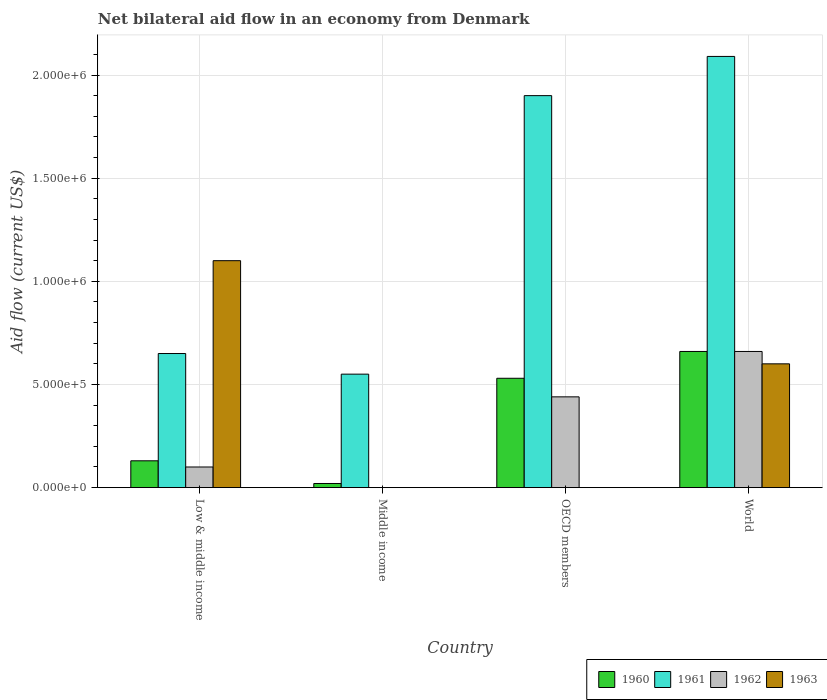How many groups of bars are there?
Keep it short and to the point. 4. What is the net bilateral aid flow in 1961 in OECD members?
Offer a terse response. 1.90e+06. What is the total net bilateral aid flow in 1961 in the graph?
Your response must be concise. 5.19e+06. What is the difference between the net bilateral aid flow in 1961 in Middle income and that in OECD members?
Provide a succinct answer. -1.35e+06. What is the difference between the net bilateral aid flow in 1961 in Low & middle income and the net bilateral aid flow in 1963 in OECD members?
Provide a short and direct response. 6.50e+05. In how many countries, is the net bilateral aid flow in 1960 greater than 600000 US$?
Provide a short and direct response. 1. What is the ratio of the net bilateral aid flow in 1961 in Middle income to that in OECD members?
Provide a short and direct response. 0.29. Is the difference between the net bilateral aid flow in 1963 in Low & middle income and World greater than the difference between the net bilateral aid flow in 1962 in Low & middle income and World?
Offer a terse response. Yes. What is the difference between the highest and the second highest net bilateral aid flow in 1961?
Provide a succinct answer. 1.44e+06. What is the difference between the highest and the lowest net bilateral aid flow in 1963?
Provide a short and direct response. 1.10e+06. In how many countries, is the net bilateral aid flow in 1961 greater than the average net bilateral aid flow in 1961 taken over all countries?
Make the answer very short. 2. Is it the case that in every country, the sum of the net bilateral aid flow in 1960 and net bilateral aid flow in 1963 is greater than the net bilateral aid flow in 1961?
Offer a terse response. No. How many bars are there?
Offer a very short reply. 13. Are all the bars in the graph horizontal?
Give a very brief answer. No. How many countries are there in the graph?
Ensure brevity in your answer.  4. What is the difference between two consecutive major ticks on the Y-axis?
Provide a short and direct response. 5.00e+05. Does the graph contain any zero values?
Make the answer very short. Yes. Does the graph contain grids?
Keep it short and to the point. Yes. How many legend labels are there?
Give a very brief answer. 4. How are the legend labels stacked?
Ensure brevity in your answer.  Horizontal. What is the title of the graph?
Ensure brevity in your answer.  Net bilateral aid flow in an economy from Denmark. What is the label or title of the X-axis?
Ensure brevity in your answer.  Country. What is the label or title of the Y-axis?
Provide a short and direct response. Aid flow (current US$). What is the Aid flow (current US$) of 1960 in Low & middle income?
Offer a very short reply. 1.30e+05. What is the Aid flow (current US$) of 1961 in Low & middle income?
Your answer should be compact. 6.50e+05. What is the Aid flow (current US$) in 1963 in Low & middle income?
Your answer should be very brief. 1.10e+06. What is the Aid flow (current US$) of 1962 in Middle income?
Give a very brief answer. 0. What is the Aid flow (current US$) in 1960 in OECD members?
Give a very brief answer. 5.30e+05. What is the Aid flow (current US$) of 1961 in OECD members?
Offer a terse response. 1.90e+06. What is the Aid flow (current US$) of 1963 in OECD members?
Your answer should be very brief. 0. What is the Aid flow (current US$) in 1961 in World?
Ensure brevity in your answer.  2.09e+06. What is the Aid flow (current US$) in 1962 in World?
Provide a succinct answer. 6.60e+05. What is the Aid flow (current US$) of 1963 in World?
Your answer should be very brief. 6.00e+05. Across all countries, what is the maximum Aid flow (current US$) of 1960?
Provide a short and direct response. 6.60e+05. Across all countries, what is the maximum Aid flow (current US$) in 1961?
Keep it short and to the point. 2.09e+06. Across all countries, what is the maximum Aid flow (current US$) of 1963?
Make the answer very short. 1.10e+06. Across all countries, what is the minimum Aid flow (current US$) in 1960?
Give a very brief answer. 2.00e+04. Across all countries, what is the minimum Aid flow (current US$) in 1961?
Provide a short and direct response. 5.50e+05. Across all countries, what is the minimum Aid flow (current US$) of 1962?
Offer a very short reply. 0. Across all countries, what is the minimum Aid flow (current US$) of 1963?
Provide a succinct answer. 0. What is the total Aid flow (current US$) in 1960 in the graph?
Make the answer very short. 1.34e+06. What is the total Aid flow (current US$) in 1961 in the graph?
Give a very brief answer. 5.19e+06. What is the total Aid flow (current US$) of 1962 in the graph?
Your answer should be compact. 1.20e+06. What is the total Aid flow (current US$) of 1963 in the graph?
Make the answer very short. 1.70e+06. What is the difference between the Aid flow (current US$) of 1960 in Low & middle income and that in Middle income?
Your response must be concise. 1.10e+05. What is the difference between the Aid flow (current US$) in 1960 in Low & middle income and that in OECD members?
Your answer should be very brief. -4.00e+05. What is the difference between the Aid flow (current US$) of 1961 in Low & middle income and that in OECD members?
Make the answer very short. -1.25e+06. What is the difference between the Aid flow (current US$) of 1962 in Low & middle income and that in OECD members?
Offer a terse response. -3.40e+05. What is the difference between the Aid flow (current US$) of 1960 in Low & middle income and that in World?
Make the answer very short. -5.30e+05. What is the difference between the Aid flow (current US$) of 1961 in Low & middle income and that in World?
Give a very brief answer. -1.44e+06. What is the difference between the Aid flow (current US$) in 1962 in Low & middle income and that in World?
Give a very brief answer. -5.60e+05. What is the difference between the Aid flow (current US$) of 1963 in Low & middle income and that in World?
Give a very brief answer. 5.00e+05. What is the difference between the Aid flow (current US$) in 1960 in Middle income and that in OECD members?
Your answer should be very brief. -5.10e+05. What is the difference between the Aid flow (current US$) in 1961 in Middle income and that in OECD members?
Your answer should be very brief. -1.35e+06. What is the difference between the Aid flow (current US$) of 1960 in Middle income and that in World?
Your answer should be compact. -6.40e+05. What is the difference between the Aid flow (current US$) in 1961 in Middle income and that in World?
Make the answer very short. -1.54e+06. What is the difference between the Aid flow (current US$) in 1960 in OECD members and that in World?
Make the answer very short. -1.30e+05. What is the difference between the Aid flow (current US$) in 1960 in Low & middle income and the Aid flow (current US$) in 1961 in Middle income?
Keep it short and to the point. -4.20e+05. What is the difference between the Aid flow (current US$) of 1960 in Low & middle income and the Aid flow (current US$) of 1961 in OECD members?
Keep it short and to the point. -1.77e+06. What is the difference between the Aid flow (current US$) of 1960 in Low & middle income and the Aid flow (current US$) of 1962 in OECD members?
Keep it short and to the point. -3.10e+05. What is the difference between the Aid flow (current US$) in 1961 in Low & middle income and the Aid flow (current US$) in 1962 in OECD members?
Provide a short and direct response. 2.10e+05. What is the difference between the Aid flow (current US$) in 1960 in Low & middle income and the Aid flow (current US$) in 1961 in World?
Your answer should be compact. -1.96e+06. What is the difference between the Aid flow (current US$) of 1960 in Low & middle income and the Aid flow (current US$) of 1962 in World?
Give a very brief answer. -5.30e+05. What is the difference between the Aid flow (current US$) in 1960 in Low & middle income and the Aid flow (current US$) in 1963 in World?
Your answer should be very brief. -4.70e+05. What is the difference between the Aid flow (current US$) in 1961 in Low & middle income and the Aid flow (current US$) in 1962 in World?
Offer a very short reply. -10000. What is the difference between the Aid flow (current US$) of 1961 in Low & middle income and the Aid flow (current US$) of 1963 in World?
Offer a terse response. 5.00e+04. What is the difference between the Aid flow (current US$) in 1962 in Low & middle income and the Aid flow (current US$) in 1963 in World?
Your answer should be compact. -5.00e+05. What is the difference between the Aid flow (current US$) in 1960 in Middle income and the Aid flow (current US$) in 1961 in OECD members?
Offer a very short reply. -1.88e+06. What is the difference between the Aid flow (current US$) in 1960 in Middle income and the Aid flow (current US$) in 1962 in OECD members?
Provide a succinct answer. -4.20e+05. What is the difference between the Aid flow (current US$) of 1960 in Middle income and the Aid flow (current US$) of 1961 in World?
Provide a succinct answer. -2.07e+06. What is the difference between the Aid flow (current US$) of 1960 in Middle income and the Aid flow (current US$) of 1962 in World?
Your answer should be compact. -6.40e+05. What is the difference between the Aid flow (current US$) in 1960 in Middle income and the Aid flow (current US$) in 1963 in World?
Make the answer very short. -5.80e+05. What is the difference between the Aid flow (current US$) in 1961 in Middle income and the Aid flow (current US$) in 1962 in World?
Provide a succinct answer. -1.10e+05. What is the difference between the Aid flow (current US$) in 1960 in OECD members and the Aid flow (current US$) in 1961 in World?
Keep it short and to the point. -1.56e+06. What is the difference between the Aid flow (current US$) of 1960 in OECD members and the Aid flow (current US$) of 1962 in World?
Give a very brief answer. -1.30e+05. What is the difference between the Aid flow (current US$) in 1960 in OECD members and the Aid flow (current US$) in 1963 in World?
Your answer should be very brief. -7.00e+04. What is the difference between the Aid flow (current US$) in 1961 in OECD members and the Aid flow (current US$) in 1962 in World?
Your answer should be compact. 1.24e+06. What is the difference between the Aid flow (current US$) in 1961 in OECD members and the Aid flow (current US$) in 1963 in World?
Offer a very short reply. 1.30e+06. What is the difference between the Aid flow (current US$) of 1962 in OECD members and the Aid flow (current US$) of 1963 in World?
Provide a short and direct response. -1.60e+05. What is the average Aid flow (current US$) of 1960 per country?
Keep it short and to the point. 3.35e+05. What is the average Aid flow (current US$) of 1961 per country?
Give a very brief answer. 1.30e+06. What is the average Aid flow (current US$) of 1962 per country?
Offer a very short reply. 3.00e+05. What is the average Aid flow (current US$) of 1963 per country?
Your answer should be very brief. 4.25e+05. What is the difference between the Aid flow (current US$) in 1960 and Aid flow (current US$) in 1961 in Low & middle income?
Ensure brevity in your answer.  -5.20e+05. What is the difference between the Aid flow (current US$) in 1960 and Aid flow (current US$) in 1962 in Low & middle income?
Offer a terse response. 3.00e+04. What is the difference between the Aid flow (current US$) in 1960 and Aid flow (current US$) in 1963 in Low & middle income?
Ensure brevity in your answer.  -9.70e+05. What is the difference between the Aid flow (current US$) of 1961 and Aid flow (current US$) of 1963 in Low & middle income?
Keep it short and to the point. -4.50e+05. What is the difference between the Aid flow (current US$) in 1960 and Aid flow (current US$) in 1961 in Middle income?
Provide a succinct answer. -5.30e+05. What is the difference between the Aid flow (current US$) of 1960 and Aid flow (current US$) of 1961 in OECD members?
Provide a short and direct response. -1.37e+06. What is the difference between the Aid flow (current US$) in 1961 and Aid flow (current US$) in 1962 in OECD members?
Your answer should be compact. 1.46e+06. What is the difference between the Aid flow (current US$) of 1960 and Aid flow (current US$) of 1961 in World?
Provide a succinct answer. -1.43e+06. What is the difference between the Aid flow (current US$) of 1960 and Aid flow (current US$) of 1963 in World?
Offer a terse response. 6.00e+04. What is the difference between the Aid flow (current US$) in 1961 and Aid flow (current US$) in 1962 in World?
Ensure brevity in your answer.  1.43e+06. What is the difference between the Aid flow (current US$) in 1961 and Aid flow (current US$) in 1963 in World?
Your answer should be very brief. 1.49e+06. What is the difference between the Aid flow (current US$) in 1962 and Aid flow (current US$) in 1963 in World?
Make the answer very short. 6.00e+04. What is the ratio of the Aid flow (current US$) in 1961 in Low & middle income to that in Middle income?
Your answer should be very brief. 1.18. What is the ratio of the Aid flow (current US$) in 1960 in Low & middle income to that in OECD members?
Keep it short and to the point. 0.25. What is the ratio of the Aid flow (current US$) of 1961 in Low & middle income to that in OECD members?
Your answer should be compact. 0.34. What is the ratio of the Aid flow (current US$) in 1962 in Low & middle income to that in OECD members?
Ensure brevity in your answer.  0.23. What is the ratio of the Aid flow (current US$) of 1960 in Low & middle income to that in World?
Offer a terse response. 0.2. What is the ratio of the Aid flow (current US$) of 1961 in Low & middle income to that in World?
Make the answer very short. 0.31. What is the ratio of the Aid flow (current US$) of 1962 in Low & middle income to that in World?
Provide a short and direct response. 0.15. What is the ratio of the Aid flow (current US$) of 1963 in Low & middle income to that in World?
Give a very brief answer. 1.83. What is the ratio of the Aid flow (current US$) in 1960 in Middle income to that in OECD members?
Provide a short and direct response. 0.04. What is the ratio of the Aid flow (current US$) in 1961 in Middle income to that in OECD members?
Your answer should be very brief. 0.29. What is the ratio of the Aid flow (current US$) in 1960 in Middle income to that in World?
Provide a succinct answer. 0.03. What is the ratio of the Aid flow (current US$) in 1961 in Middle income to that in World?
Ensure brevity in your answer.  0.26. What is the ratio of the Aid flow (current US$) in 1960 in OECD members to that in World?
Keep it short and to the point. 0.8. What is the ratio of the Aid flow (current US$) in 1962 in OECD members to that in World?
Ensure brevity in your answer.  0.67. What is the difference between the highest and the second highest Aid flow (current US$) in 1960?
Your answer should be very brief. 1.30e+05. What is the difference between the highest and the second highest Aid flow (current US$) in 1961?
Your answer should be compact. 1.90e+05. What is the difference between the highest and the second highest Aid flow (current US$) in 1962?
Give a very brief answer. 2.20e+05. What is the difference between the highest and the lowest Aid flow (current US$) in 1960?
Provide a short and direct response. 6.40e+05. What is the difference between the highest and the lowest Aid flow (current US$) in 1961?
Provide a short and direct response. 1.54e+06. What is the difference between the highest and the lowest Aid flow (current US$) in 1962?
Your answer should be very brief. 6.60e+05. What is the difference between the highest and the lowest Aid flow (current US$) in 1963?
Offer a terse response. 1.10e+06. 